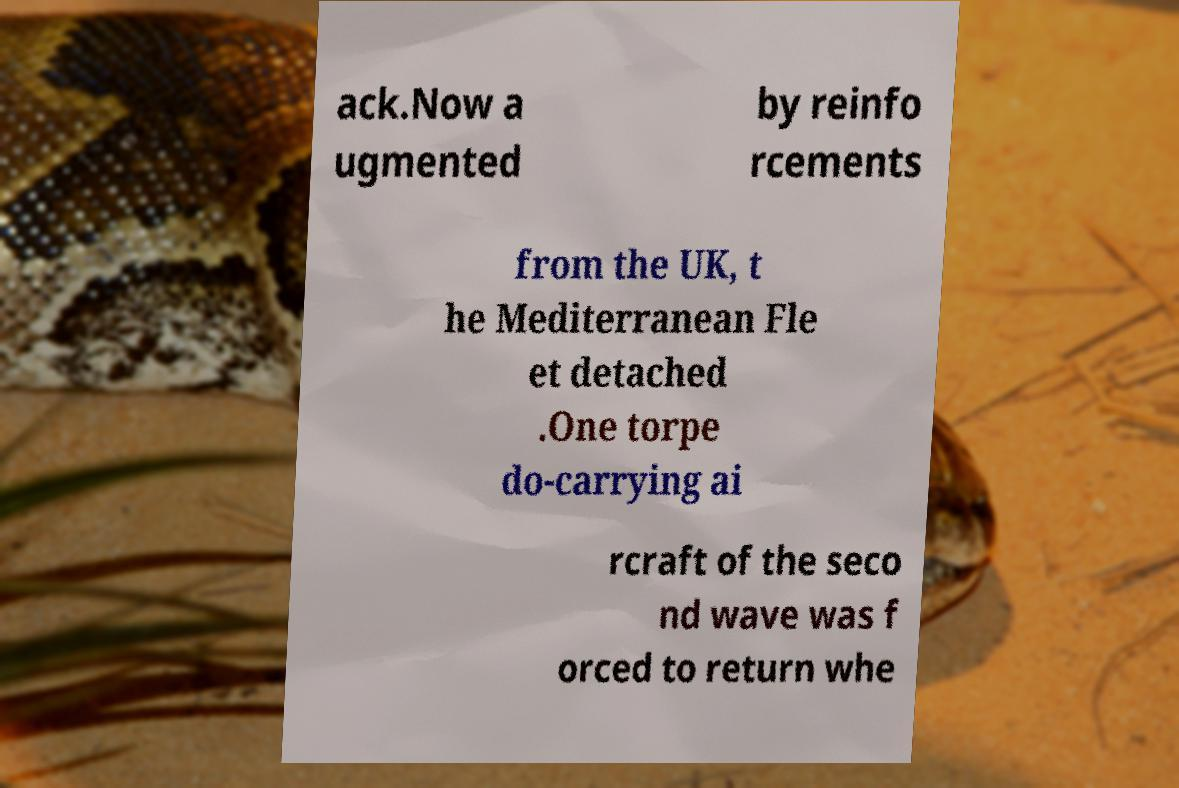Please read and relay the text visible in this image. What does it say? ack.Now a ugmented by reinfo rcements from the UK, t he Mediterranean Fle et detached .One torpe do-carrying ai rcraft of the seco nd wave was f orced to return whe 